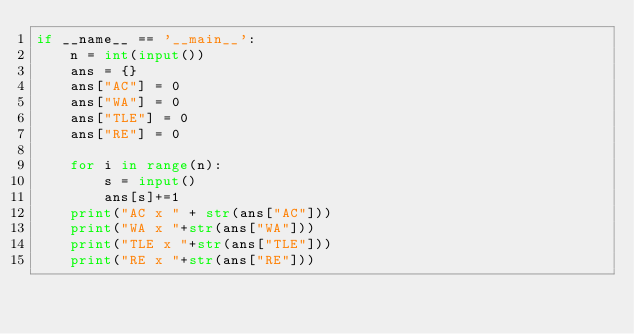<code> <loc_0><loc_0><loc_500><loc_500><_Python_>if __name__ == '__main__':
    n = int(input())
    ans = {}
    ans["AC"] = 0
    ans["WA"] = 0
    ans["TLE"] = 0
    ans["RE"] = 0

    for i in range(n):
        s = input()
        ans[s]+=1
    print("AC x " + str(ans["AC"]))
    print("WA x "+str(ans["WA"]))
    print("TLE x "+str(ans["TLE"]))
    print("RE x "+str(ans["RE"]))
</code> 